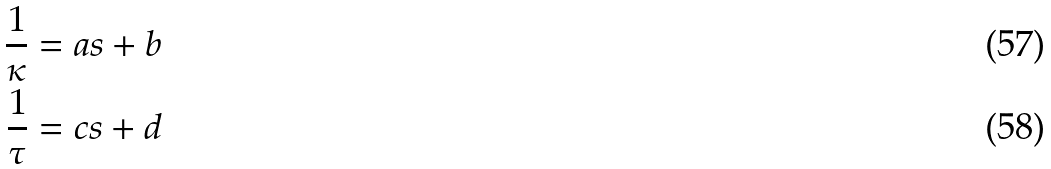Convert formula to latex. <formula><loc_0><loc_0><loc_500><loc_500>\frac { 1 } { \kappa } & = a s + b \\ \frac { 1 } { \tau } & = c s + d</formula> 